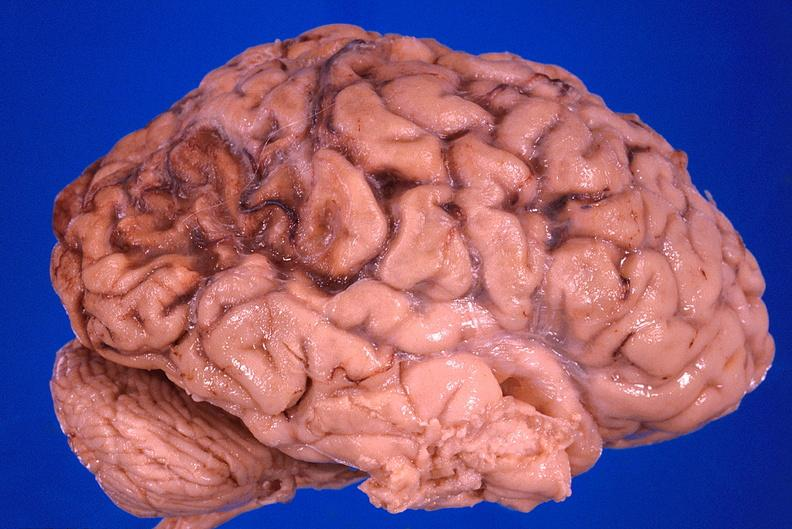what is present?
Answer the question using a single word or phrase. Nervous 